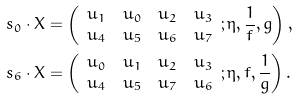Convert formula to latex. <formula><loc_0><loc_0><loc_500><loc_500>s _ { 0 } & \cdot X = \left ( \begin{array} { c c c c } u _ { 1 } & u _ { 0 } & u _ { 2 } & u _ { 3 } \\ u _ { 4 } & u _ { 5 } & u _ { 6 } & u _ { 7 } \end{array} ; \eta , \frac { 1 } { f } , g \right ) , \\ s _ { 6 } & \cdot X = \left ( \begin{array} { c c c c } u _ { 0 } & u _ { 1 } & u _ { 2 } & u _ { 3 } \\ u _ { 4 } & u _ { 5 } & u _ { 7 } & u _ { 6 } \end{array} ; \eta , f , \frac { 1 } { g } \right ) .</formula> 